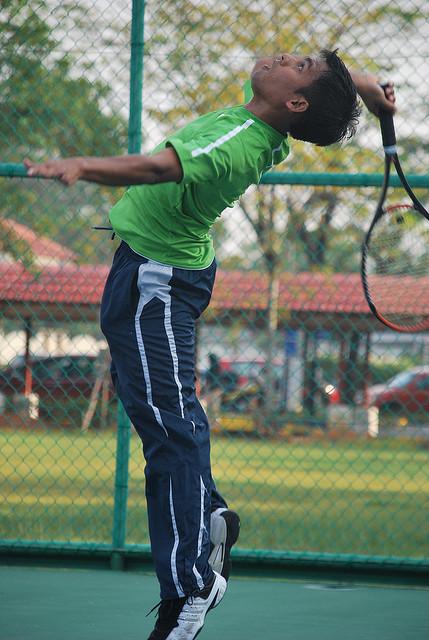What is the man's wearing?
Short answer required. Shirt. What sport are they playing?
Give a very brief answer. Tennis. What direction is the man looking?
Answer briefly. Up. 